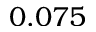Convert formula to latex. <formula><loc_0><loc_0><loc_500><loc_500>0 . 0 7 5</formula> 